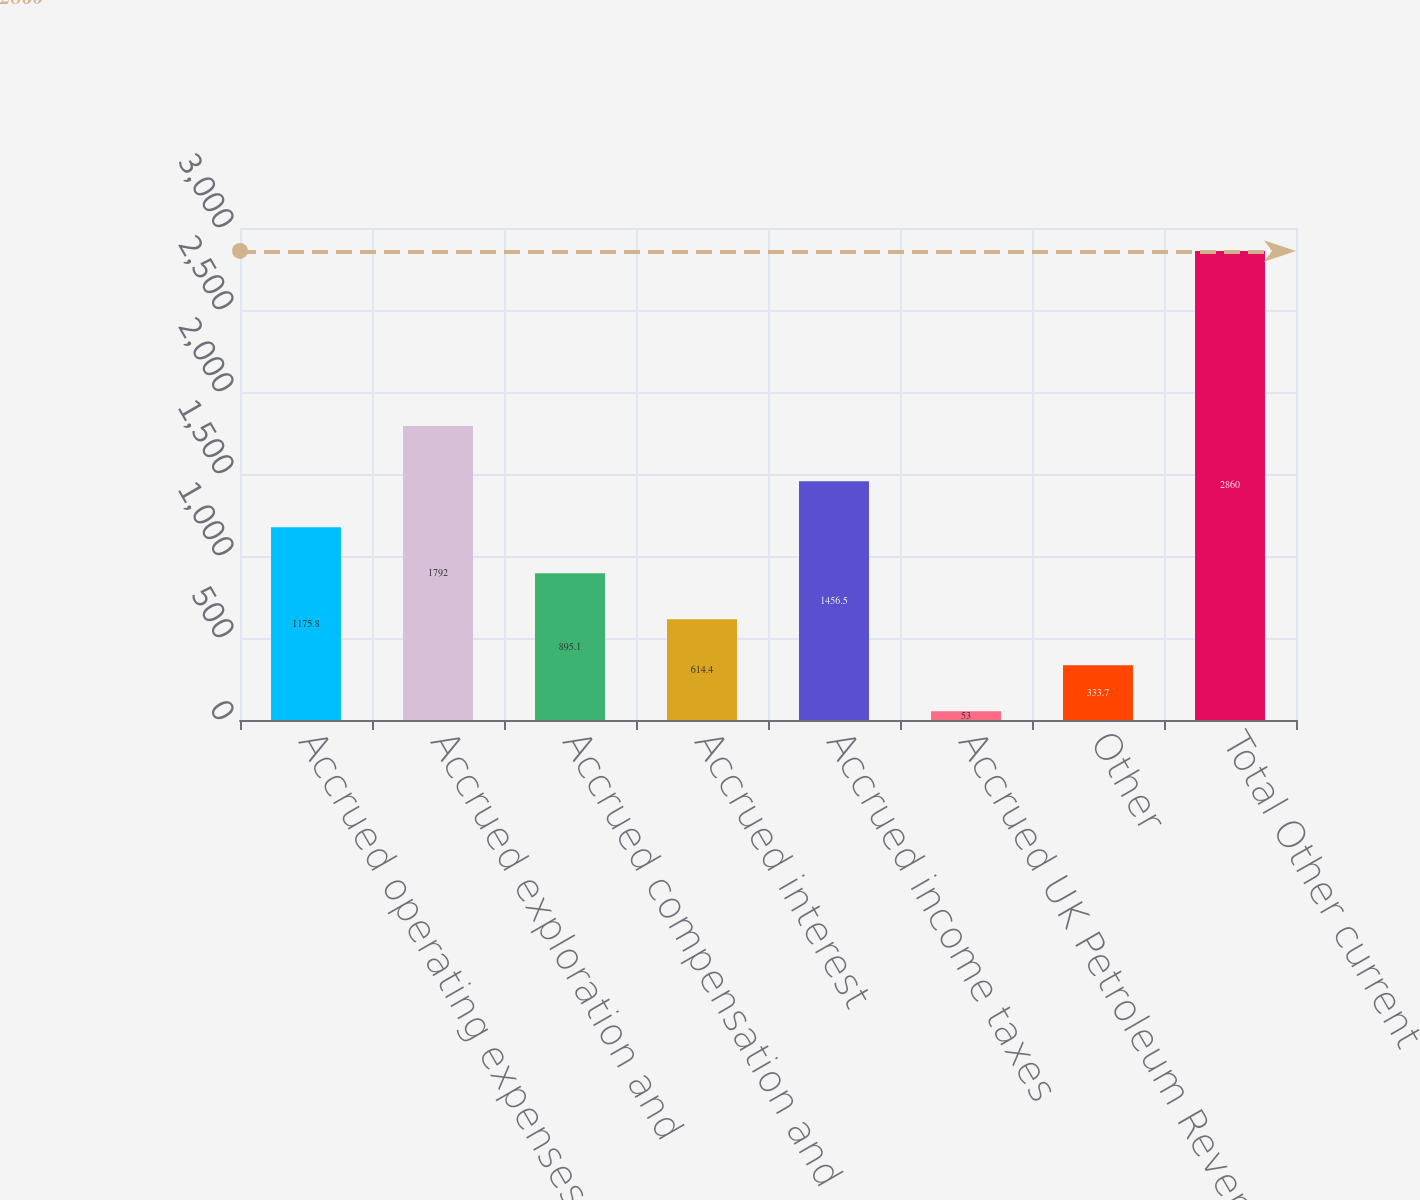Convert chart to OTSL. <chart><loc_0><loc_0><loc_500><loc_500><bar_chart><fcel>Accrued operating expenses<fcel>Accrued exploration and<fcel>Accrued compensation and<fcel>Accrued interest<fcel>Accrued income taxes<fcel>Accrued UK Petroleum Revenue<fcel>Other<fcel>Total Other current<nl><fcel>1175.8<fcel>1792<fcel>895.1<fcel>614.4<fcel>1456.5<fcel>53<fcel>333.7<fcel>2860<nl></chart> 